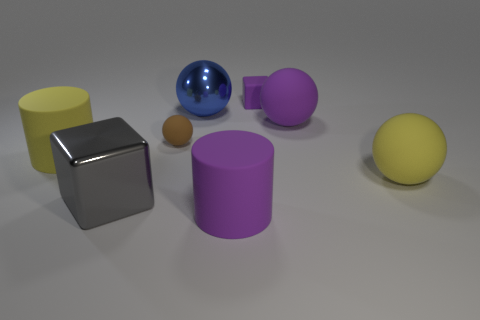There is a object that is behind the purple ball and left of the purple matte block; what material is it made of?
Offer a terse response. Metal. Is there a brown matte object that has the same size as the matte cube?
Offer a very short reply. Yes. What number of tiny brown matte cubes are there?
Give a very brief answer. 0. How many things are in front of the small purple thing?
Your answer should be compact. 7. Does the big gray block have the same material as the blue ball?
Ensure brevity in your answer.  Yes. How many purple objects are both behind the large yellow matte cylinder and in front of the small purple rubber block?
Offer a very short reply. 1. How many other objects are the same color as the large metallic sphere?
Your answer should be very brief. 0. What number of green things are small cubes or big things?
Offer a terse response. 0. The rubber block is what size?
Your response must be concise. Small. How many matte objects are either big purple spheres or gray objects?
Give a very brief answer. 1. 